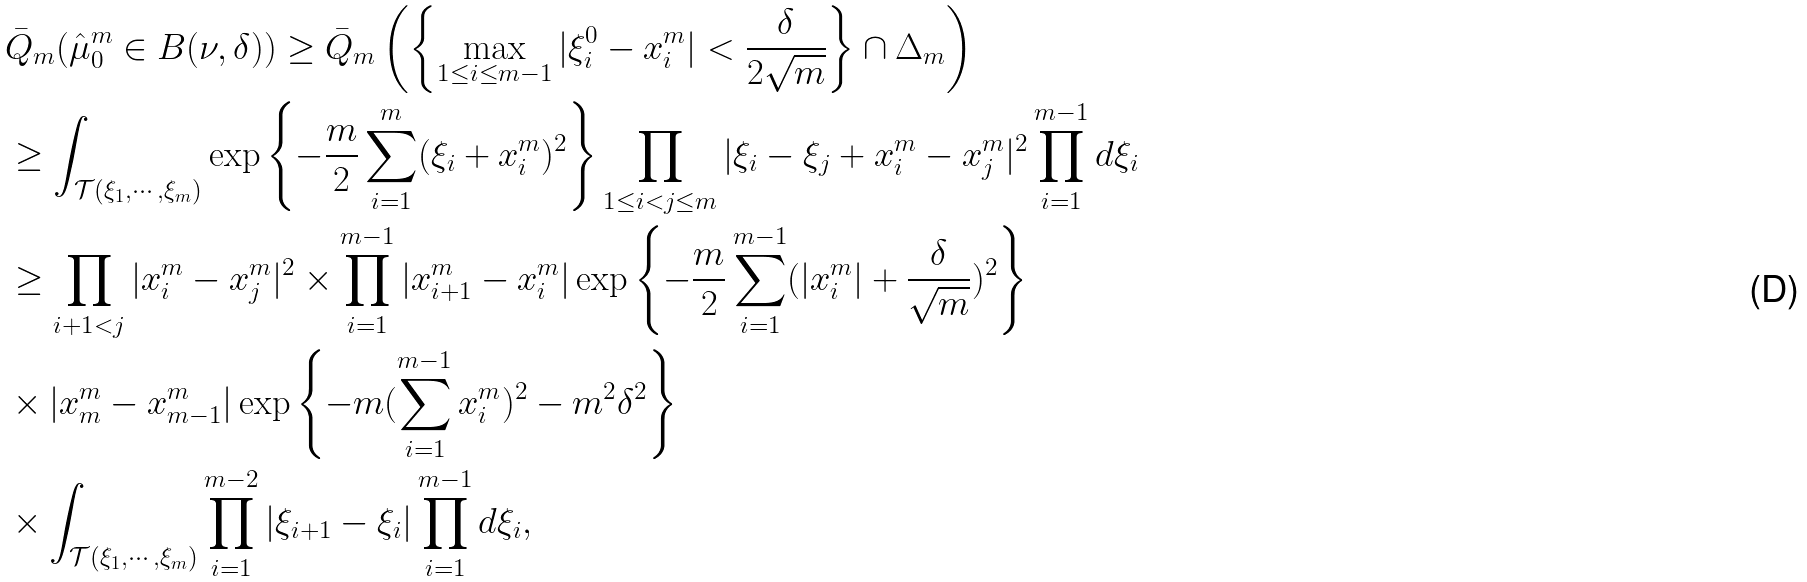Convert formula to latex. <formula><loc_0><loc_0><loc_500><loc_500>& \bar { Q } _ { m } ( \hat { \mu } _ { 0 } ^ { m } \in B ( \nu , \delta ) ) \geq \bar { Q } _ { m } \left ( \left \{ \max _ { 1 \leq i \leq m - 1 } | \xi _ { i } ^ { 0 } - x _ { i } ^ { m } | < \frac { \delta } { 2 \sqrt { m } } \right \} \cap \Delta _ { m } \right ) \\ & \geq \int _ { \mathcal { T } ( \xi _ { 1 } , \cdots , \xi _ { m } ) } \exp \left \{ - \frac { m } { 2 } \sum _ { i = 1 } ^ { m } ( \xi _ { i } + x _ { i } ^ { m } ) ^ { 2 } \right \} \prod _ { 1 \leq i < j \leq m } | \xi _ { i } - \xi _ { j } + x _ { i } ^ { m } - x _ { j } ^ { m } | ^ { 2 } \prod _ { i = 1 } ^ { m - 1 } d \xi _ { i } \\ & \geq \prod _ { i + 1 < j } | x _ { i } ^ { m } - x _ { j } ^ { m } | ^ { 2 } \times \prod _ { i = 1 } ^ { m - 1 } | x _ { i + 1 } ^ { m } - x _ { i } ^ { m } | \exp \left \{ - \frac { m } { 2 } \sum _ { i = 1 } ^ { m - 1 } ( | x _ { i } ^ { m } | + \frac { \delta } { \sqrt { m } } ) ^ { 2 } \right \} \\ & \times | x _ { m } ^ { m } - x _ { m - 1 } ^ { m } | \exp \left \{ - m ( \sum _ { i = 1 } ^ { m - 1 } x _ { i } ^ { m } ) ^ { 2 } - m ^ { 2 } \delta ^ { 2 } \right \} \\ & \times \int _ { \mathcal { T } ( \xi _ { 1 } , \cdots , \xi _ { m } ) } \prod _ { i = 1 } ^ { m - 2 } | \xi _ { i + 1 } - \xi _ { i } | \prod _ { i = 1 } ^ { m - 1 } d \xi _ { i } ,</formula> 